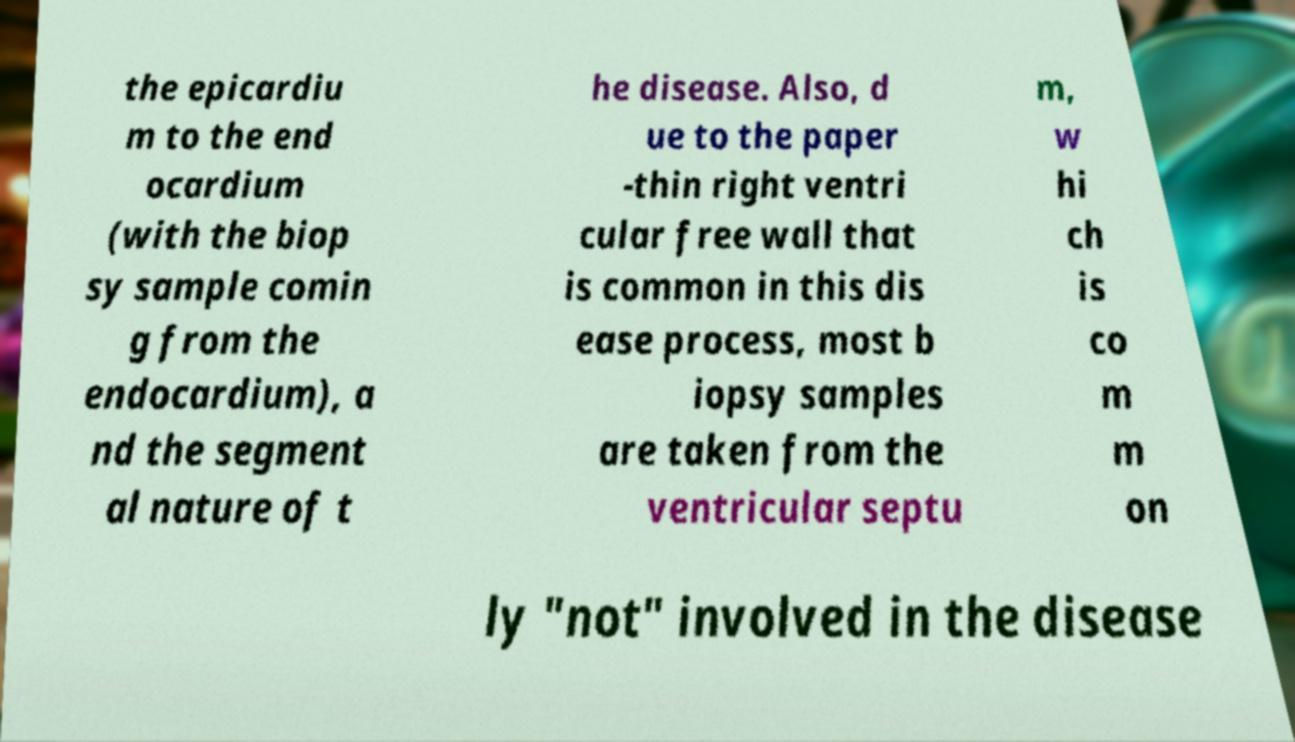Could you assist in decoding the text presented in this image and type it out clearly? the epicardiu m to the end ocardium (with the biop sy sample comin g from the endocardium), a nd the segment al nature of t he disease. Also, d ue to the paper -thin right ventri cular free wall that is common in this dis ease process, most b iopsy samples are taken from the ventricular septu m, w hi ch is co m m on ly "not" involved in the disease 